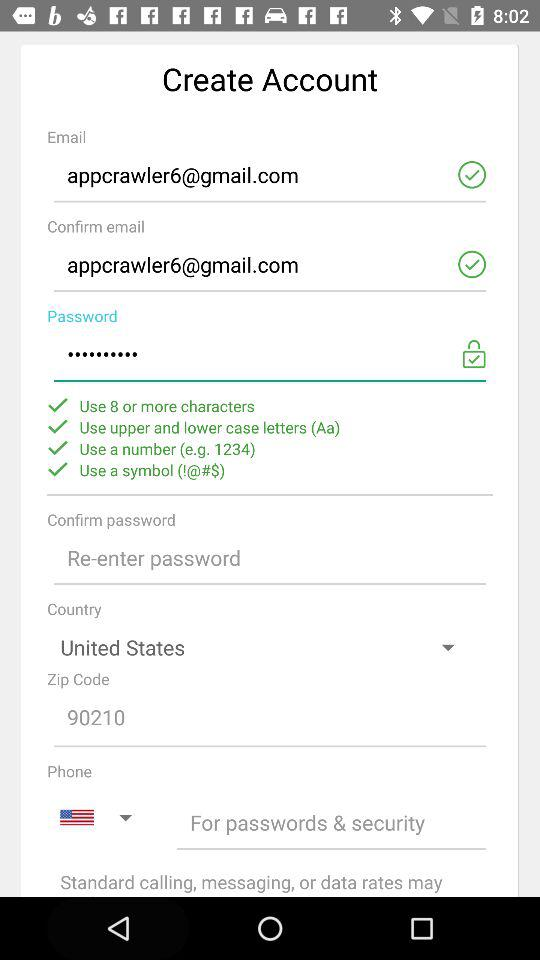What is the email ID of the user? The email ID is appcrawler6@gmail.com. 